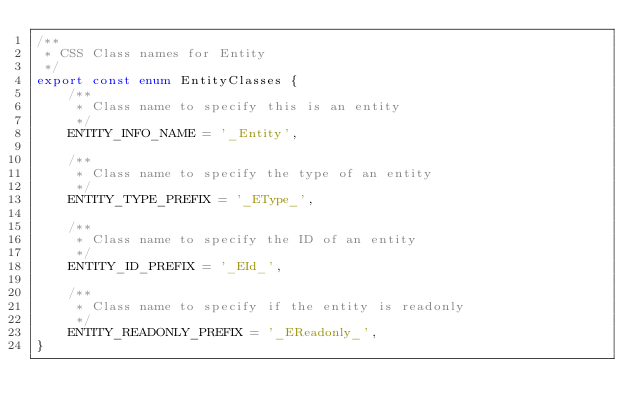Convert code to text. <code><loc_0><loc_0><loc_500><loc_500><_TypeScript_>/**
 * CSS Class names for Entity
 */
export const enum EntityClasses {
    /**
     * Class name to specify this is an entity
     */
    ENTITY_INFO_NAME = '_Entity',

    /**
     * Class name to specify the type of an entity
     */
    ENTITY_TYPE_PREFIX = '_EType_',

    /**
     * Class name to specify the ID of an entity
     */
    ENTITY_ID_PREFIX = '_EId_',

    /**
     * Class name to specify if the entity is readonly
     */
    ENTITY_READONLY_PREFIX = '_EReadonly_',
}
</code> 